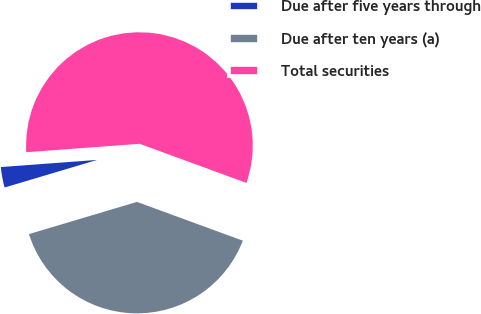<chart> <loc_0><loc_0><loc_500><loc_500><pie_chart><fcel>Due after five years through<fcel>Due after ten years (a)<fcel>Total securities<nl><fcel>3.43%<fcel>39.8%<fcel>56.77%<nl></chart> 